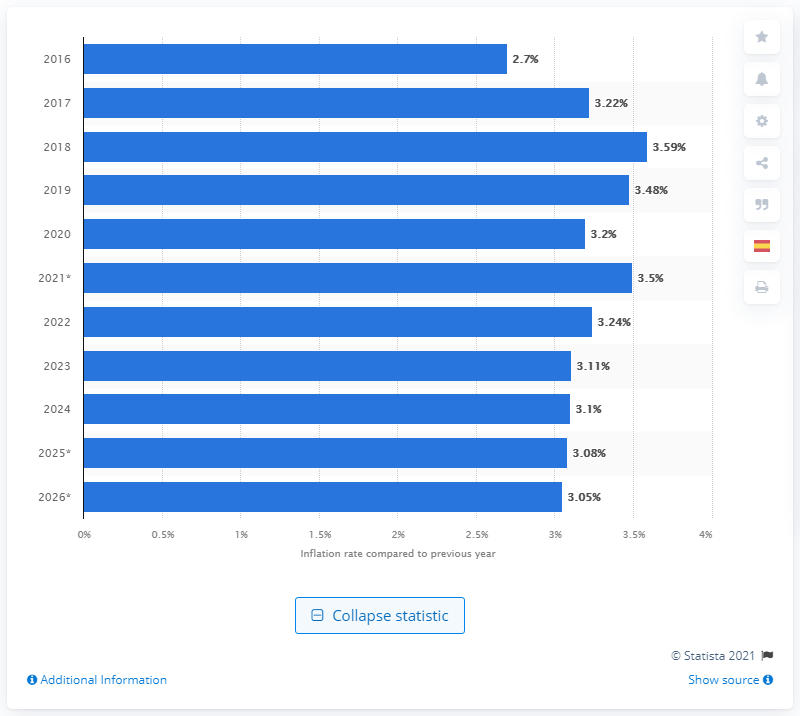Draw attention to some important aspects in this diagram. In 2020, the worldwide inflation rate was 3.22%. 